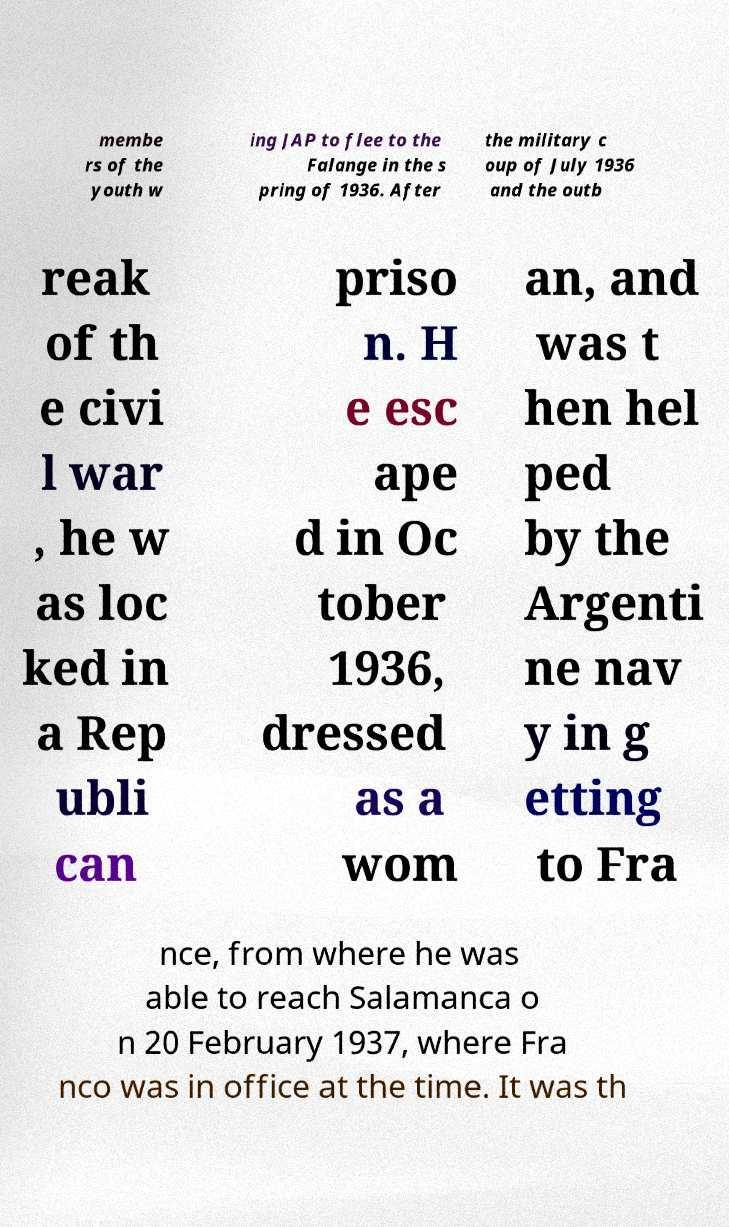I need the written content from this picture converted into text. Can you do that? membe rs of the youth w ing JAP to flee to the Falange in the s pring of 1936. After the military c oup of July 1936 and the outb reak of th e civi l war , he w as loc ked in a Rep ubli can priso n. H e esc ape d in Oc tober 1936, dressed as a wom an, and was t hen hel ped by the Argenti ne nav y in g etting to Fra nce, from where he was able to reach Salamanca o n 20 February 1937, where Fra nco was in office at the time. It was th 